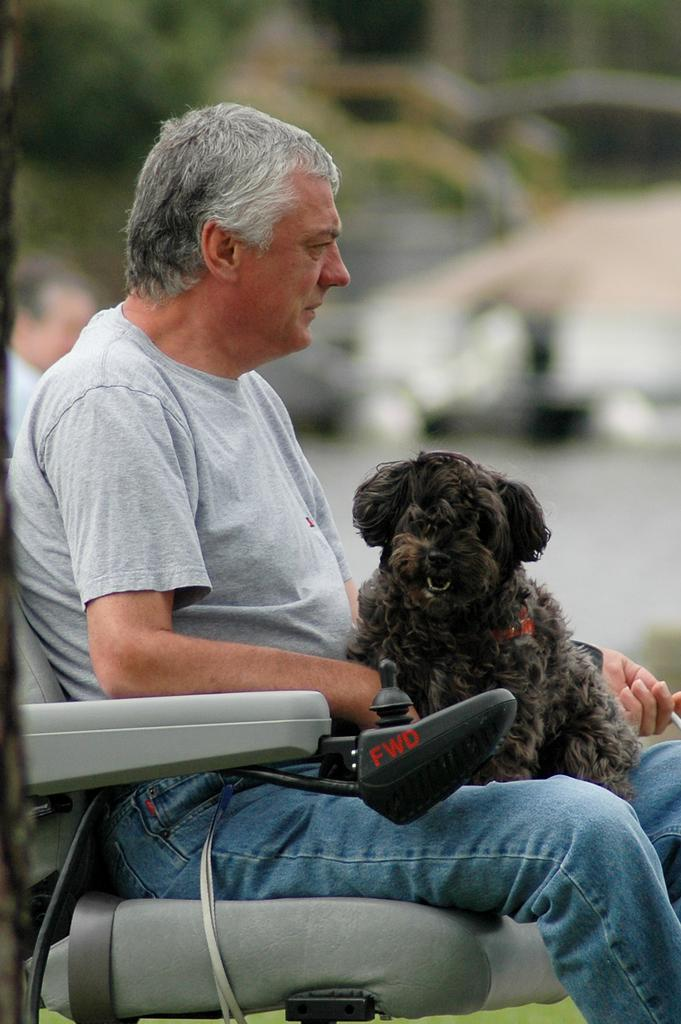Who is the main subject in the image? There is an old man in the image. What is the old man doing in the image? The old man is sitting on a chair. Is there any other living creature in the image besides the old man? Yes, there is a dog in the image. How is the dog interacting with the old man? The dog is in the old man's lap. What type of organization does the old man belong to in the image? There is no information about the old man belonging to any organization in the image. What type of thread is being used by the cook in the image? There is no cook or thread present in the image. 